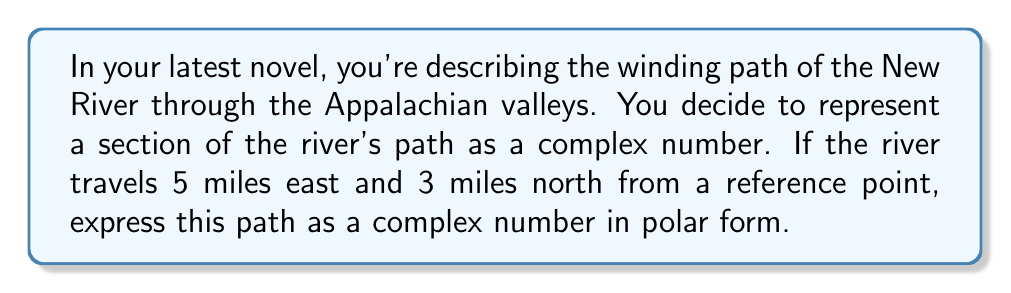Solve this math problem. To solve this problem, we'll follow these steps:

1) First, we need to represent the river's path as a complex number in rectangular form. The real part represents the east-west direction, and the imaginary part represents the north-south direction.

   $z = 5 + 3i$

2) To convert this to polar form, we need to find the modulus (r) and the argument (θ).

3) The modulus is the distance from the origin to the point (5, 3). We can calculate this using the Pythagorean theorem:

   $r = \sqrt{5^2 + 3^2} = \sqrt{34}$

4) The argument is the angle the line from the origin to (5, 3) makes with the positive real axis. We can find this using the arctangent function:

   $\theta = \tan^{-1}(\frac{3}{5})$

5) However, we typically express the argument in radians. We can leave it as $\tan^{-1}(\frac{3}{5})$ or calculate it:

   $\theta \approx 0.5404$ radians

6) The polar form of a complex number is expressed as $r(\cos\theta + i\sin\theta)$ or $re^{i\theta}$.

Therefore, the polar form of the complex number is:

$$\sqrt{34}(\cos(\tan^{-1}(\frac{3}{5})) + i\sin(\tan^{-1}(\frac{3}{5})))$$

or

$$\sqrt{34}e^{i\tan^{-1}(\frac{3}{5})}$$
Answer: $\sqrt{34}(\cos(\tan^{-1}(\frac{3}{5})) + i\sin(\tan^{-1}(\frac{3}{5})))$ or $\sqrt{34}e^{i\tan^{-1}(\frac{3}{5})}$ 